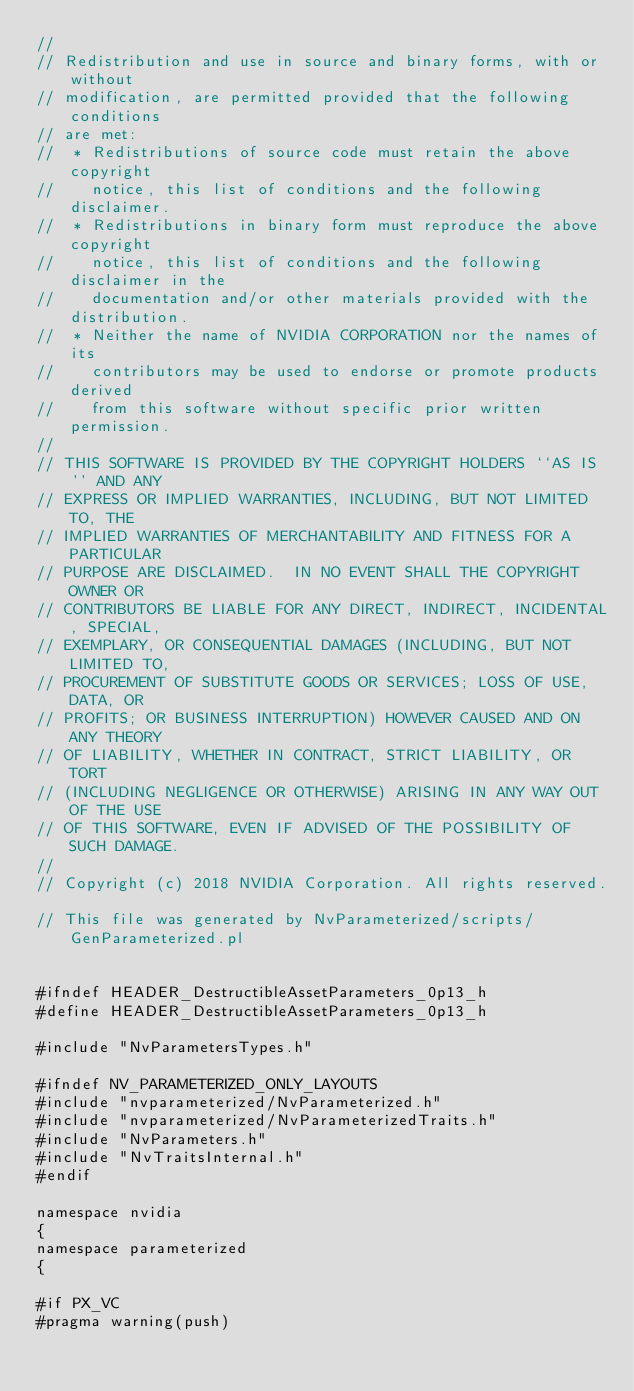<code> <loc_0><loc_0><loc_500><loc_500><_C_>//
// Redistribution and use in source and binary forms, with or without
// modification, are permitted provided that the following conditions
// are met:
//  * Redistributions of source code must retain the above copyright
//    notice, this list of conditions and the following disclaimer.
//  * Redistributions in binary form must reproduce the above copyright
//    notice, this list of conditions and the following disclaimer in the
//    documentation and/or other materials provided with the distribution.
//  * Neither the name of NVIDIA CORPORATION nor the names of its
//    contributors may be used to endorse or promote products derived
//    from this software without specific prior written permission.
//
// THIS SOFTWARE IS PROVIDED BY THE COPYRIGHT HOLDERS ``AS IS'' AND ANY
// EXPRESS OR IMPLIED WARRANTIES, INCLUDING, BUT NOT LIMITED TO, THE
// IMPLIED WARRANTIES OF MERCHANTABILITY AND FITNESS FOR A PARTICULAR
// PURPOSE ARE DISCLAIMED.  IN NO EVENT SHALL THE COPYRIGHT OWNER OR
// CONTRIBUTORS BE LIABLE FOR ANY DIRECT, INDIRECT, INCIDENTAL, SPECIAL,
// EXEMPLARY, OR CONSEQUENTIAL DAMAGES (INCLUDING, BUT NOT LIMITED TO,
// PROCUREMENT OF SUBSTITUTE GOODS OR SERVICES; LOSS OF USE, DATA, OR
// PROFITS; OR BUSINESS INTERRUPTION) HOWEVER CAUSED AND ON ANY THEORY
// OF LIABILITY, WHETHER IN CONTRACT, STRICT LIABILITY, OR TORT
// (INCLUDING NEGLIGENCE OR OTHERWISE) ARISING IN ANY WAY OUT OF THE USE
// OF THIS SOFTWARE, EVEN IF ADVISED OF THE POSSIBILITY OF SUCH DAMAGE.
//
// Copyright (c) 2018 NVIDIA Corporation. All rights reserved.

// This file was generated by NvParameterized/scripts/GenParameterized.pl


#ifndef HEADER_DestructibleAssetParameters_0p13_h
#define HEADER_DestructibleAssetParameters_0p13_h

#include "NvParametersTypes.h"

#ifndef NV_PARAMETERIZED_ONLY_LAYOUTS
#include "nvparameterized/NvParameterized.h"
#include "nvparameterized/NvParameterizedTraits.h"
#include "NvParameters.h"
#include "NvTraitsInternal.h"
#endif

namespace nvidia
{
namespace parameterized
{

#if PX_VC
#pragma warning(push)</code> 